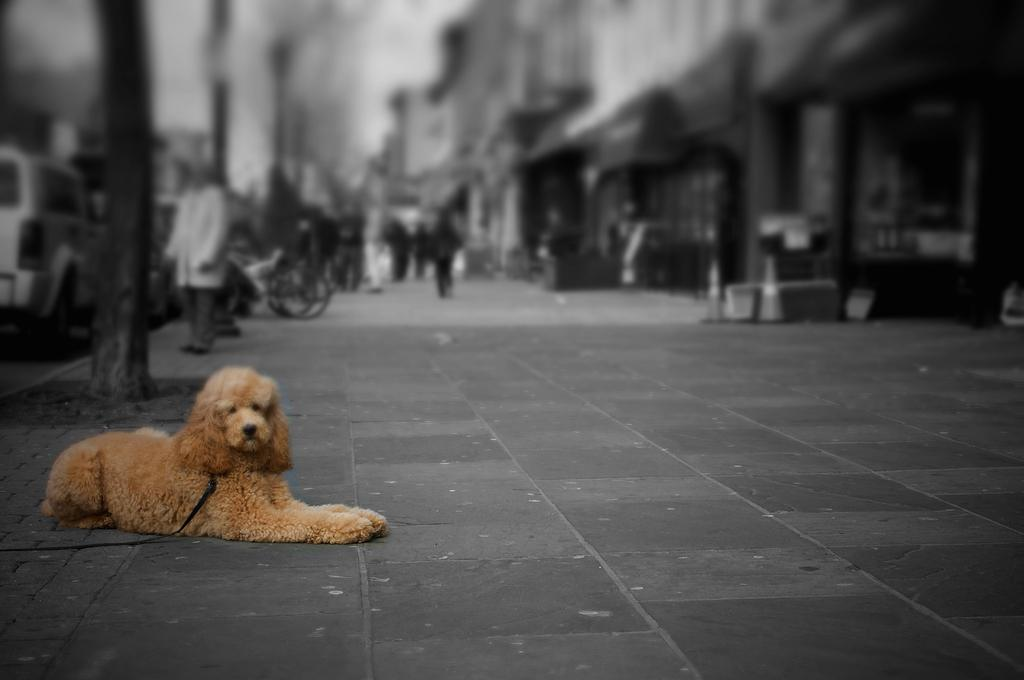What is the main subject of the image? There is a dog sitting on the road. What can be seen in the background of the image? There are trees, vehicles, a group of people, and buildings in the background of the image. What type of glue is the dog using to stick to the road in the image? There is no glue present in the image, and the dog is not using any glue to stick to the road. 